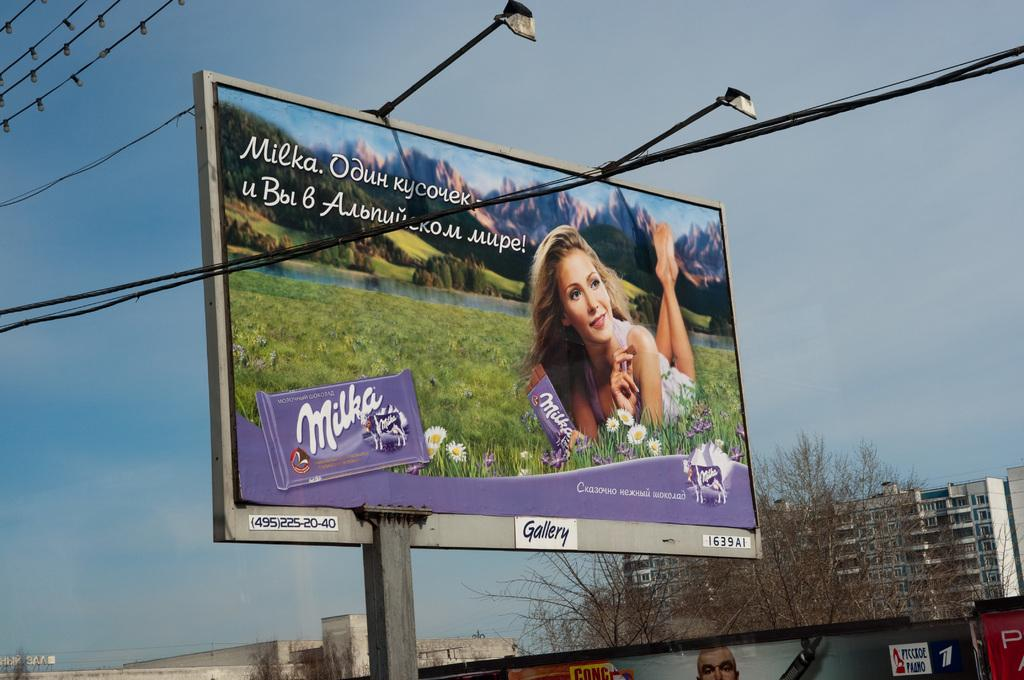<image>
Give a short and clear explanation of the subsequent image. A billboard for Milka chocolate shows a woman laying in a field enjoying a piece of chocolate 